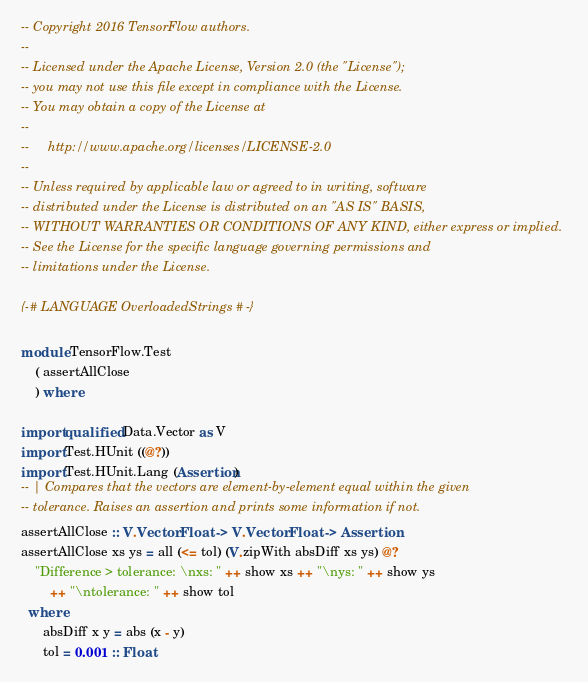Convert code to text. <code><loc_0><loc_0><loc_500><loc_500><_Haskell_>-- Copyright 2016 TensorFlow authors.
--
-- Licensed under the Apache License, Version 2.0 (the "License");
-- you may not use this file except in compliance with the License.
-- You may obtain a copy of the License at
--
--     http://www.apache.org/licenses/LICENSE-2.0
--
-- Unless required by applicable law or agreed to in writing, software
-- distributed under the License is distributed on an "AS IS" BASIS,
-- WITHOUT WARRANTIES OR CONDITIONS OF ANY KIND, either express or implied.
-- See the License for the specific language governing permissions and
-- limitations under the License.

{-# LANGUAGE OverloadedStrings #-}

module TensorFlow.Test
    ( assertAllClose
    ) where

import qualified Data.Vector as V
import Test.HUnit ((@?))
import Test.HUnit.Lang (Assertion)
-- | Compares that the vectors are element-by-element equal within the given
-- tolerance. Raises an assertion and prints some information if not.
assertAllClose :: V.Vector Float -> V.Vector Float -> Assertion
assertAllClose xs ys = all (<= tol) (V.zipWith absDiff xs ys) @?
    "Difference > tolerance: \nxs: " ++ show xs ++ "\nys: " ++ show ys
        ++ "\ntolerance: " ++ show tol
  where
      absDiff x y = abs (x - y)
      tol = 0.001 :: Float
</code> 